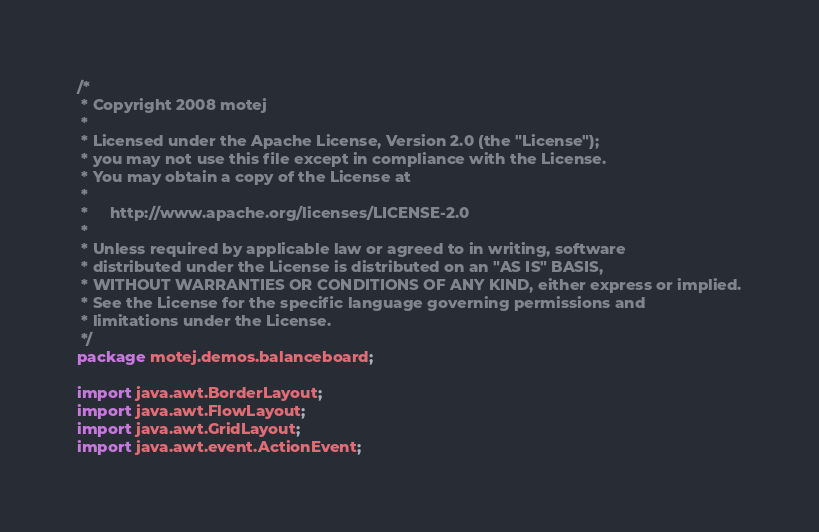Convert code to text. <code><loc_0><loc_0><loc_500><loc_500><_Java_>/*
 * Copyright 2008 motej
 *
 * Licensed under the Apache License, Version 2.0 (the "License");
 * you may not use this file except in compliance with the License.
 * You may obtain a copy of the License at
 *
 *     http://www.apache.org/licenses/LICENSE-2.0
 *
 * Unless required by applicable law or agreed to in writing, software
 * distributed under the License is distributed on an "AS IS" BASIS,
 * WITHOUT WARRANTIES OR CONDITIONS OF ANY KIND, either express or implied.
 * See the License for the specific language governing permissions and
 * limitations under the License. 
 */
package motej.demos.balanceboard;

import java.awt.BorderLayout;
import java.awt.FlowLayout;
import java.awt.GridLayout;
import java.awt.event.ActionEvent;
</code> 